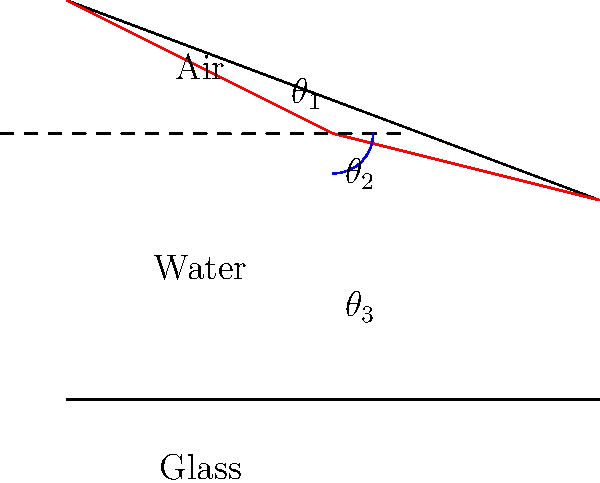As light travels through different media, its path changes due to refraction. In the diagram, a light ray passes from air into water and then into glass. If the angle of incidence in air ($\theta_1$) is 45°, and the refractive indices of air, water, and glass are 1.00, 1.33, and 1.50 respectively, determine the angle of refraction in the glass ($\theta_3$). Express your answer in degrees, rounded to the nearest whole number. To solve this problem, we'll use Snell's Law and apply it twice:

1. First, for the air-water interface:
   $$n_1 \sin(\theta_1) = n_2 \sin(\theta_2)$$
   Where $n_1 = 1.00$ (air), $n_2 = 1.33$ (water), and $\theta_1 = 45°$

2. Rearrange to solve for $\theta_2$:
   $$\theta_2 = \arcsin(\frac{n_1 \sin(\theta_1)}{n_2})$$
   $$\theta_2 = \arcsin(\frac{1.00 \sin(45°)}{1.33}) \approx 32.0°$$

3. Now, apply Snell's Law again for the water-glass interface:
   $$n_2 \sin(\theta_2) = n_3 \sin(\theta_3)$$
   Where $n_2 = 1.33$ (water), $n_3 = 1.50$ (glass), and $\theta_2 = 32.0°$

4. Rearrange to solve for $\theta_3$:
   $$\theta_3 = \arcsin(\frac{n_2 \sin(\theta_2)}{n_3})$$
   $$\theta_3 = \arcsin(\frac{1.33 \sin(32.0°)}{1.50}) \approx 28.0°$$

5. Round to the nearest whole number: 28°
Answer: 28° 